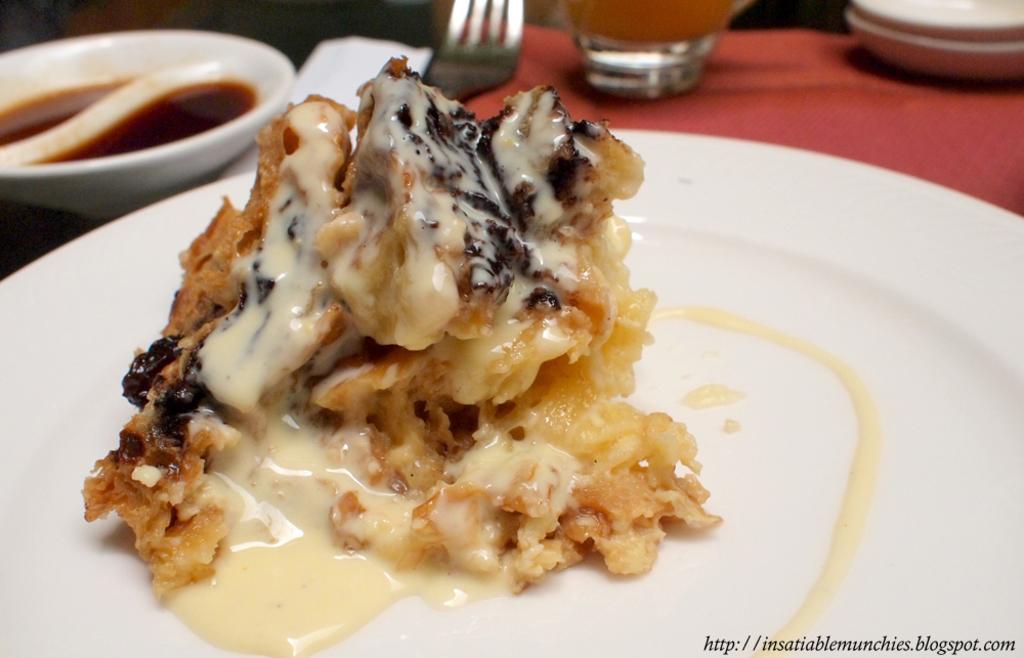Can you describe this image briefly? In this picture I can see food items on the plate and in a bowl , there is a spoon, a fork, a glass and an object on the table, and there is a watermark on the image. 